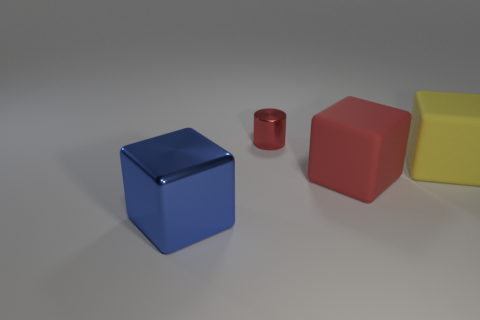Add 1 big red rubber objects. How many objects exist? 5 Subtract all cubes. How many objects are left? 1 Subtract 0 green blocks. How many objects are left? 4 Subtract all yellow spheres. Subtract all yellow cubes. How many objects are left? 3 Add 4 blue metallic blocks. How many blue metallic blocks are left? 5 Add 1 large yellow things. How many large yellow things exist? 2 